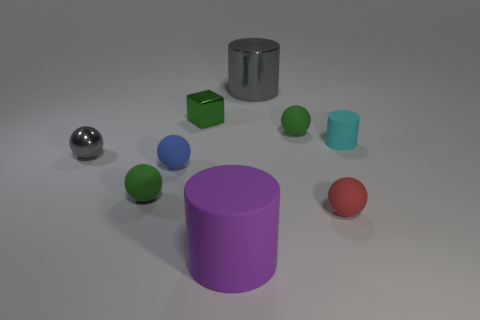There is a matte sphere behind the gray thing left of the cylinder left of the large gray thing; how big is it?
Give a very brief answer. Small. Does the cylinder in front of the red ball have the same material as the tiny green thing that is to the left of the cube?
Provide a short and direct response. Yes. What number of other things are the same color as the small metal cube?
Provide a short and direct response. 2. How many things are small green rubber things in front of the blue object or gray objects that are to the left of the large gray metal thing?
Your answer should be very brief. 2. There is a object left of the green matte sphere in front of the tiny gray shiny thing; what size is it?
Offer a terse response. Small. What size is the gray cylinder?
Your answer should be very brief. Large. Do the large cylinder in front of the small gray metallic ball and the matte cylinder behind the big matte thing have the same color?
Provide a short and direct response. No. What number of other things are there of the same material as the big purple cylinder
Keep it short and to the point. 5. Is there a small green shiny cylinder?
Ensure brevity in your answer.  No. Do the cylinder behind the metal cube and the purple thing have the same material?
Your answer should be compact. No. 